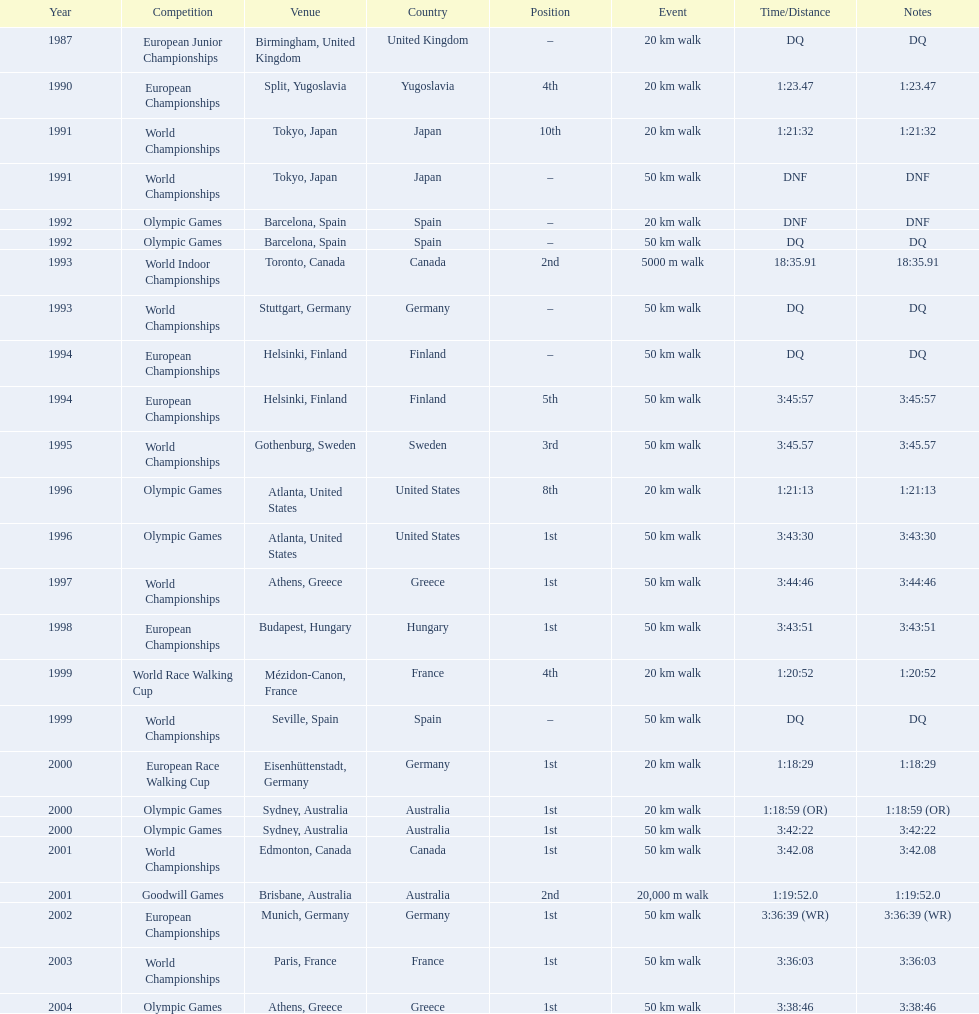Which venue is listed the most? Athens, Greece. 